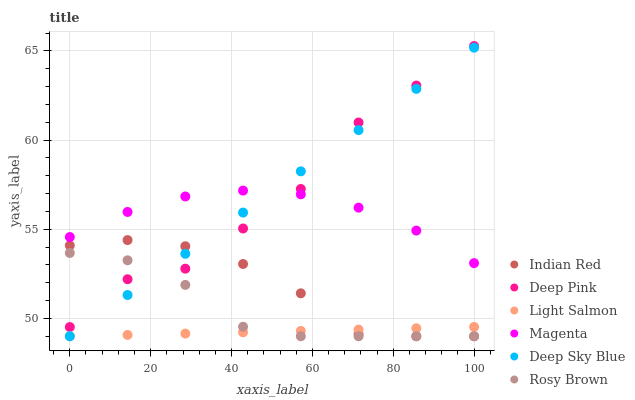Does Light Salmon have the minimum area under the curve?
Answer yes or no. Yes. Does Deep Sky Blue have the maximum area under the curve?
Answer yes or no. Yes. Does Deep Pink have the minimum area under the curve?
Answer yes or no. No. Does Deep Pink have the maximum area under the curve?
Answer yes or no. No. Is Light Salmon the smoothest?
Answer yes or no. Yes. Is Deep Pink the roughest?
Answer yes or no. Yes. Is Indian Red the smoothest?
Answer yes or no. No. Is Indian Red the roughest?
Answer yes or no. No. Does Light Salmon have the lowest value?
Answer yes or no. Yes. Does Deep Pink have the lowest value?
Answer yes or no. No. Does Deep Pink have the highest value?
Answer yes or no. Yes. Does Indian Red have the highest value?
Answer yes or no. No. Is Light Salmon less than Deep Pink?
Answer yes or no. Yes. Is Magenta greater than Indian Red?
Answer yes or no. Yes. Does Deep Pink intersect Indian Red?
Answer yes or no. Yes. Is Deep Pink less than Indian Red?
Answer yes or no. No. Is Deep Pink greater than Indian Red?
Answer yes or no. No. Does Light Salmon intersect Deep Pink?
Answer yes or no. No. 